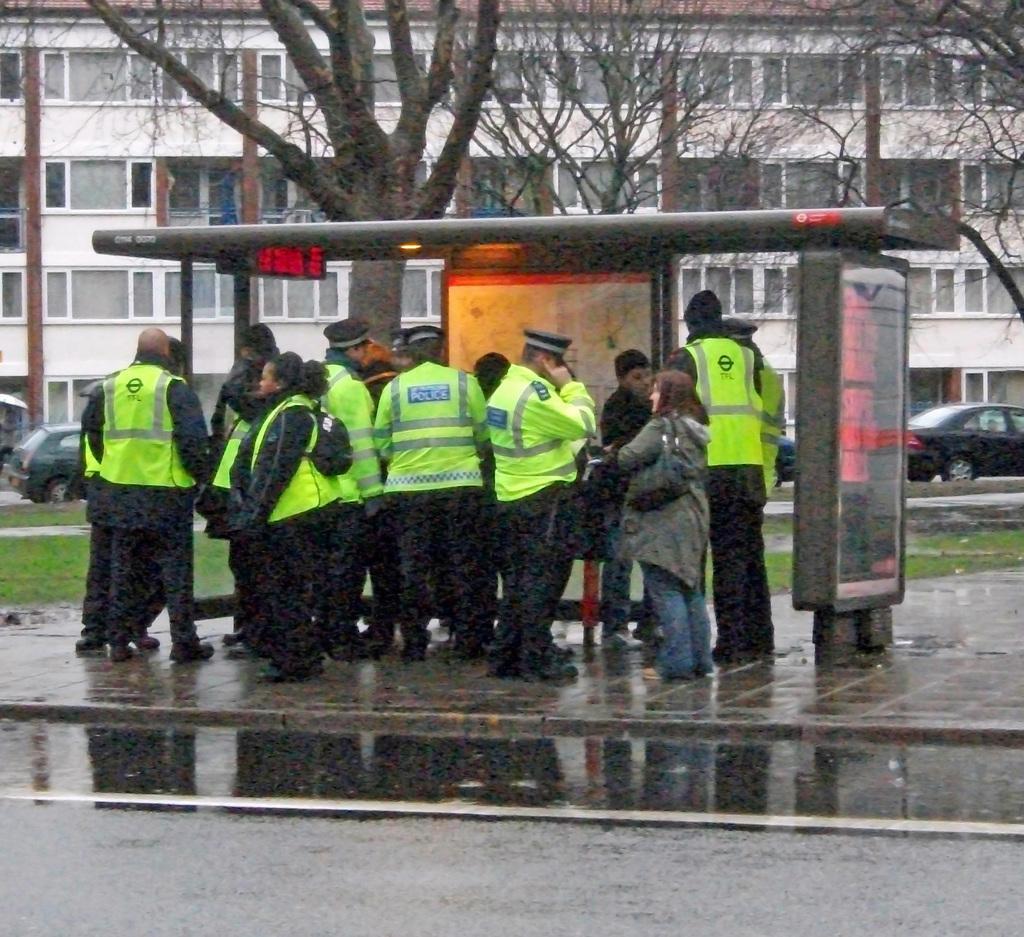Could you give a brief overview of what you see in this image? In this picture there are few persons standing and there are few vehicles,trees and a building in the background. 